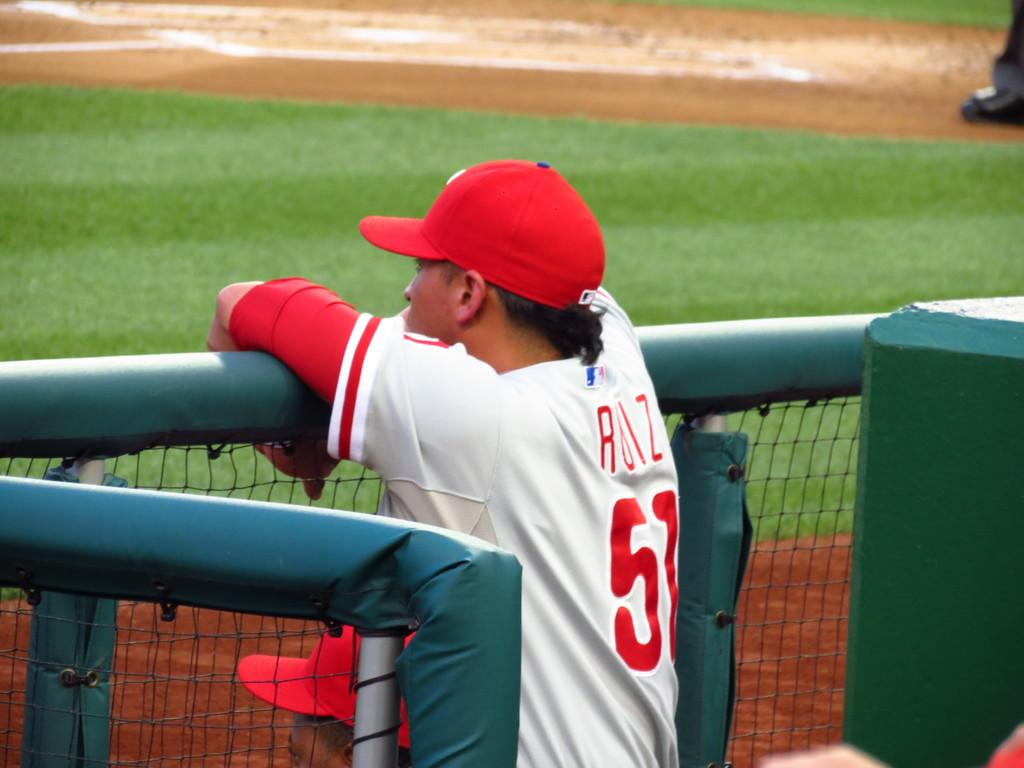<image>
Provide a brief description of the given image. Baseball player 51 is standing in the dugout, watching the game. 